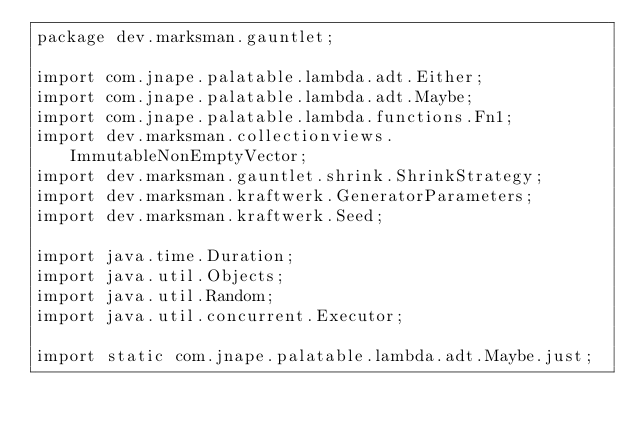Convert code to text. <code><loc_0><loc_0><loc_500><loc_500><_Java_>package dev.marksman.gauntlet;

import com.jnape.palatable.lambda.adt.Either;
import com.jnape.palatable.lambda.adt.Maybe;
import com.jnape.palatable.lambda.functions.Fn1;
import dev.marksman.collectionviews.ImmutableNonEmptyVector;
import dev.marksman.gauntlet.shrink.ShrinkStrategy;
import dev.marksman.kraftwerk.GeneratorParameters;
import dev.marksman.kraftwerk.Seed;

import java.time.Duration;
import java.util.Objects;
import java.util.Random;
import java.util.concurrent.Executor;

import static com.jnape.palatable.lambda.adt.Maybe.just;</code> 